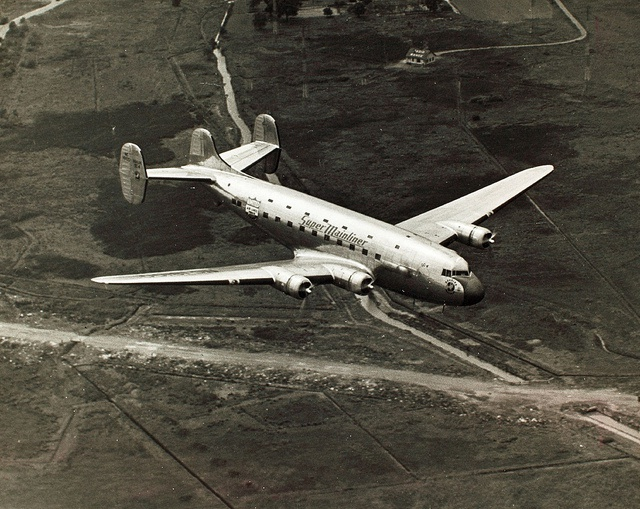Describe the objects in this image and their specific colors. I can see a airplane in gray, ivory, black, and darkgray tones in this image. 